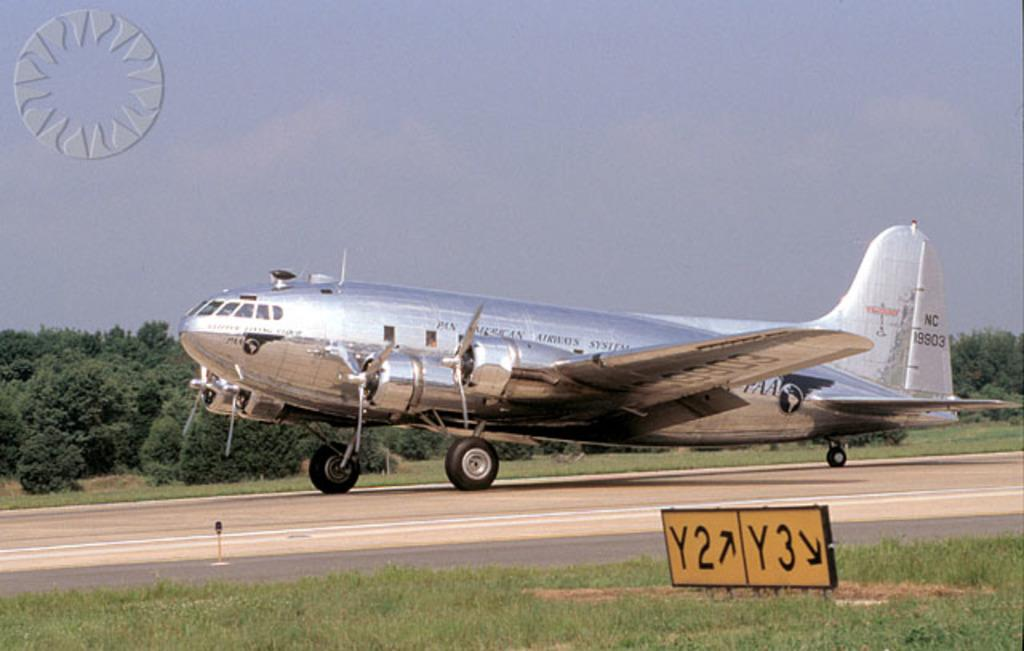Provide a one-sentence caption for the provided image. A silver Pan American Airways System's aircraft on the runway. 